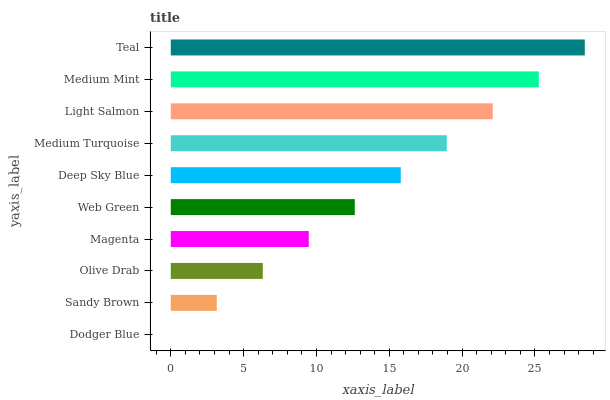Is Dodger Blue the minimum?
Answer yes or no. Yes. Is Teal the maximum?
Answer yes or no. Yes. Is Sandy Brown the minimum?
Answer yes or no. No. Is Sandy Brown the maximum?
Answer yes or no. No. Is Sandy Brown greater than Dodger Blue?
Answer yes or no. Yes. Is Dodger Blue less than Sandy Brown?
Answer yes or no. Yes. Is Dodger Blue greater than Sandy Brown?
Answer yes or no. No. Is Sandy Brown less than Dodger Blue?
Answer yes or no. No. Is Deep Sky Blue the high median?
Answer yes or no. Yes. Is Web Green the low median?
Answer yes or no. Yes. Is Web Green the high median?
Answer yes or no. No. Is Deep Sky Blue the low median?
Answer yes or no. No. 